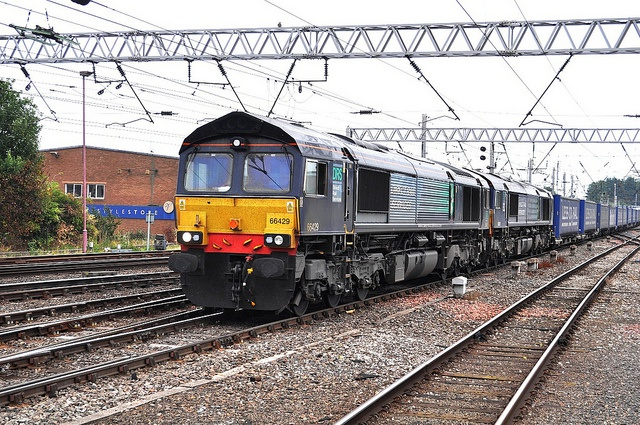Describe the objects in this image and their specific colors. I can see a train in white, black, gray, lightgray, and darkgray tones in this image. 